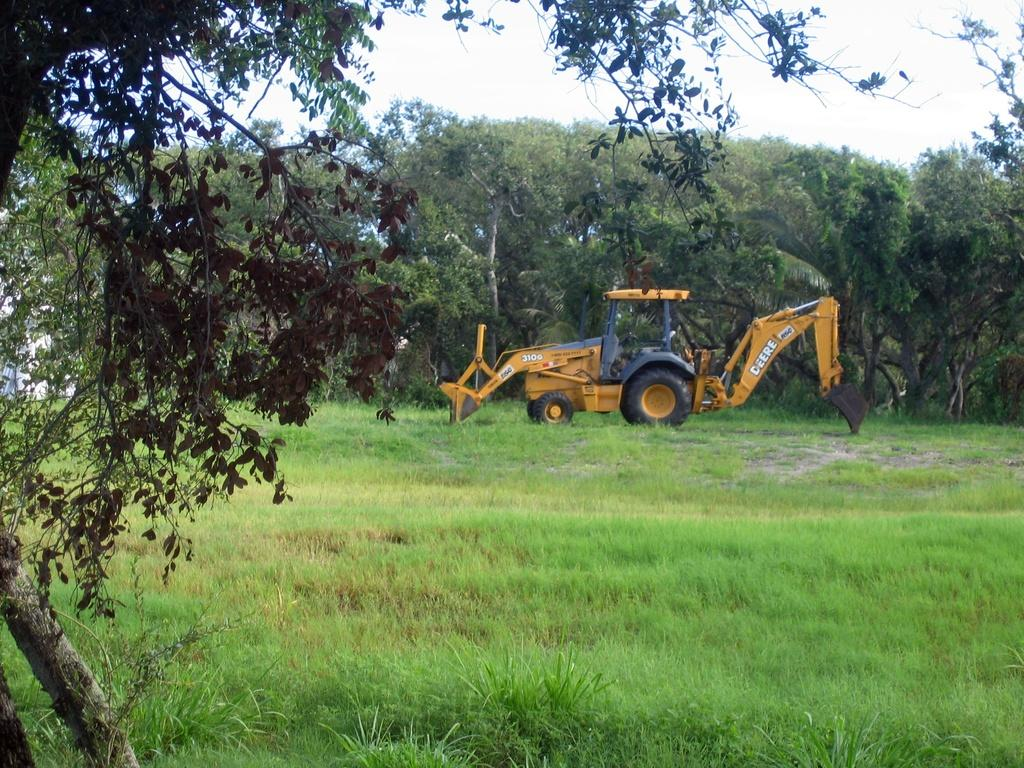What type of natural environment is visible in the image? There is grass and trees in the image, indicating a natural environment. Can you describe the vehicle in the image? There is a yellow-colored vehicle in the image. What is written on the vehicle? Something is written on the vehicle, but the specific message cannot be determined from the image. What type of sticks are being played in the image? There are no sticks or musical instruments present in the image. Is the farmer in the image using the vehicle to transport crops? There is no farmer or indication of crop transportation in the image. 